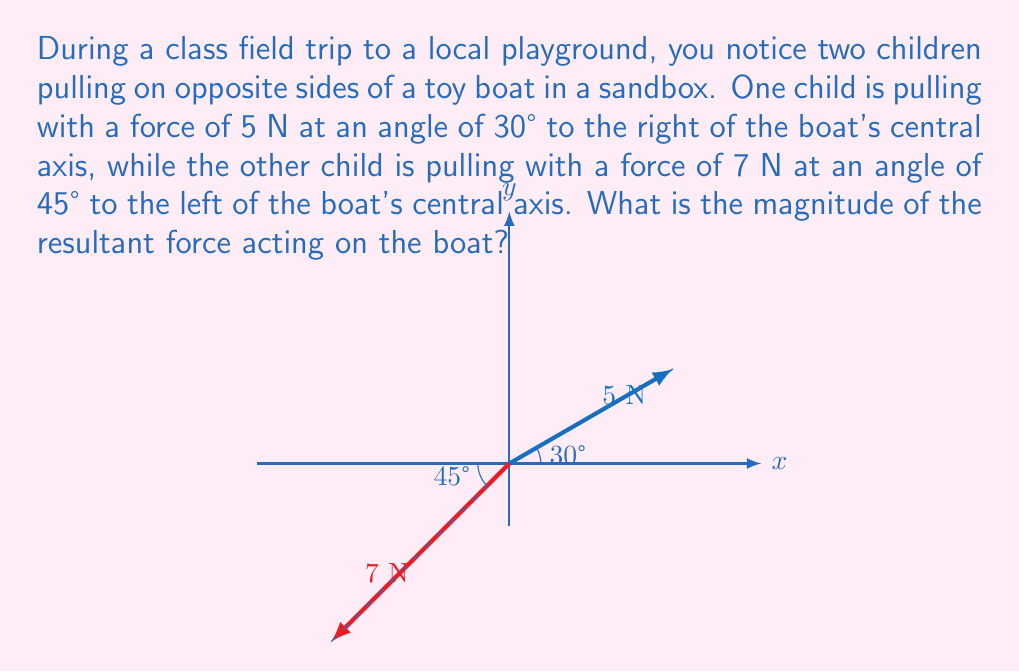Provide a solution to this math problem. Let's solve this step-by-step:

1) First, we need to break down each force into its x and y components using trigonometry.

2) For the 5 N force at 30°:
   $F_{1x} = 5 \cos 30° = 5 \cdot \frac{\sqrt{3}}{2} = 2.5\sqrt{3}$ N
   $F_{1y} = 5 \sin 30° = 5 \cdot \frac{1}{2} = 2.5$ N

3) For the 7 N force at 45°:
   $F_{2x} = -7 \cos 45° = -7 \cdot \frac{\sqrt{2}}{2} = -3.5\sqrt{2}$ N (negative because it's to the left)
   $F_{2y} = 7 \sin 45° = 7 \cdot \frac{\sqrt{2}}{2} = 3.5\sqrt{2}$ N

4) Now, we sum the x and y components:
   $F_x = F_{1x} + F_{2x} = 2.5\sqrt{3} - 3.5\sqrt{2}$ N
   $F_y = F_{1y} + F_{2y} = 2.5 + 3.5\sqrt{2}$ N

5) The resultant force is the vector sum of these components. We can find its magnitude using the Pythagorean theorem:

   $F_{resultant} = \sqrt{F_x^2 + F_y^2}$

6) Substituting the values:
   $F_{resultant} = \sqrt{(2.5\sqrt{3} - 3.5\sqrt{2})^2 + (2.5 + 3.5\sqrt{2})^2}$

7) Simplifying (you may use a calculator for this step):
   $F_{resultant} \approx 6.71$ N
Answer: $6.71$ N 